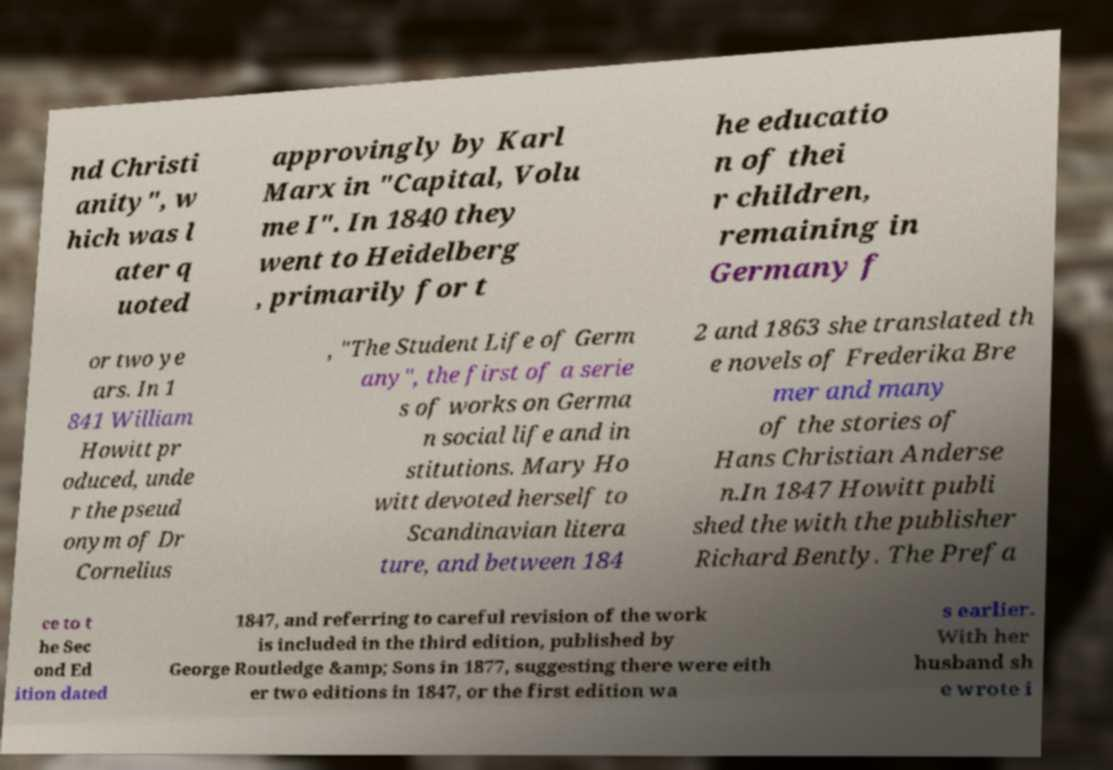Can you accurately transcribe the text from the provided image for me? nd Christi anity", w hich was l ater q uoted approvingly by Karl Marx in "Capital, Volu me I". In 1840 they went to Heidelberg , primarily for t he educatio n of thei r children, remaining in Germany f or two ye ars. In 1 841 William Howitt pr oduced, unde r the pseud onym of Dr Cornelius , "The Student Life of Germ any", the first of a serie s of works on Germa n social life and in stitutions. Mary Ho witt devoted herself to Scandinavian litera ture, and between 184 2 and 1863 she translated th e novels of Frederika Bre mer and many of the stories of Hans Christian Anderse n.In 1847 Howitt publi shed the with the publisher Richard Bently. The Prefa ce to t he Sec ond Ed ition dated 1847, and referring to careful revision of the work is included in the third edition, published by George Routledge &amp; Sons in 1877, suggesting there were eith er two editions in 1847, or the first edition wa s earlier. With her husband sh e wrote i 